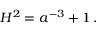Convert formula to latex. <formula><loc_0><loc_0><loc_500><loc_500>H ^ { 2 } = a ^ { - 3 } + 1 \, .</formula> 